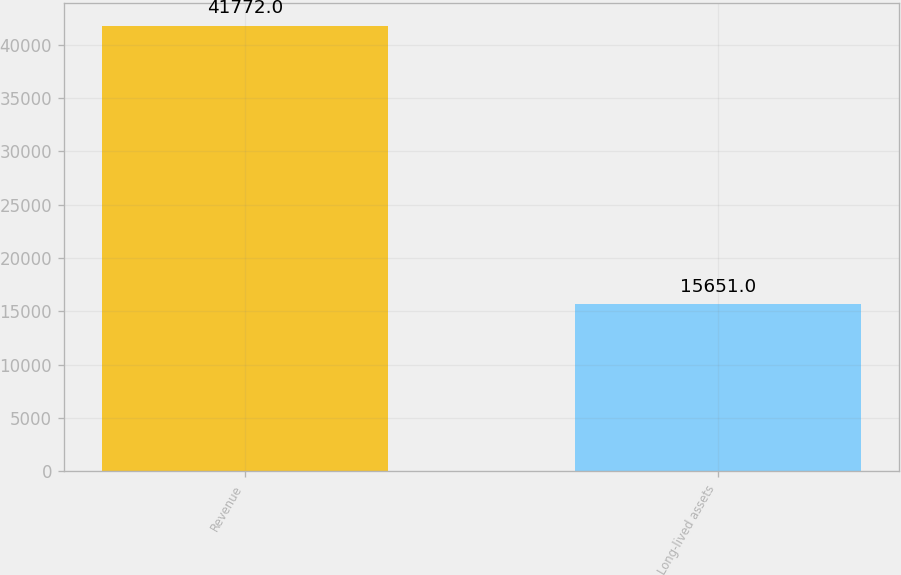Convert chart. <chart><loc_0><loc_0><loc_500><loc_500><bar_chart><fcel>Revenue<fcel>Long-lived assets<nl><fcel>41772<fcel>15651<nl></chart> 